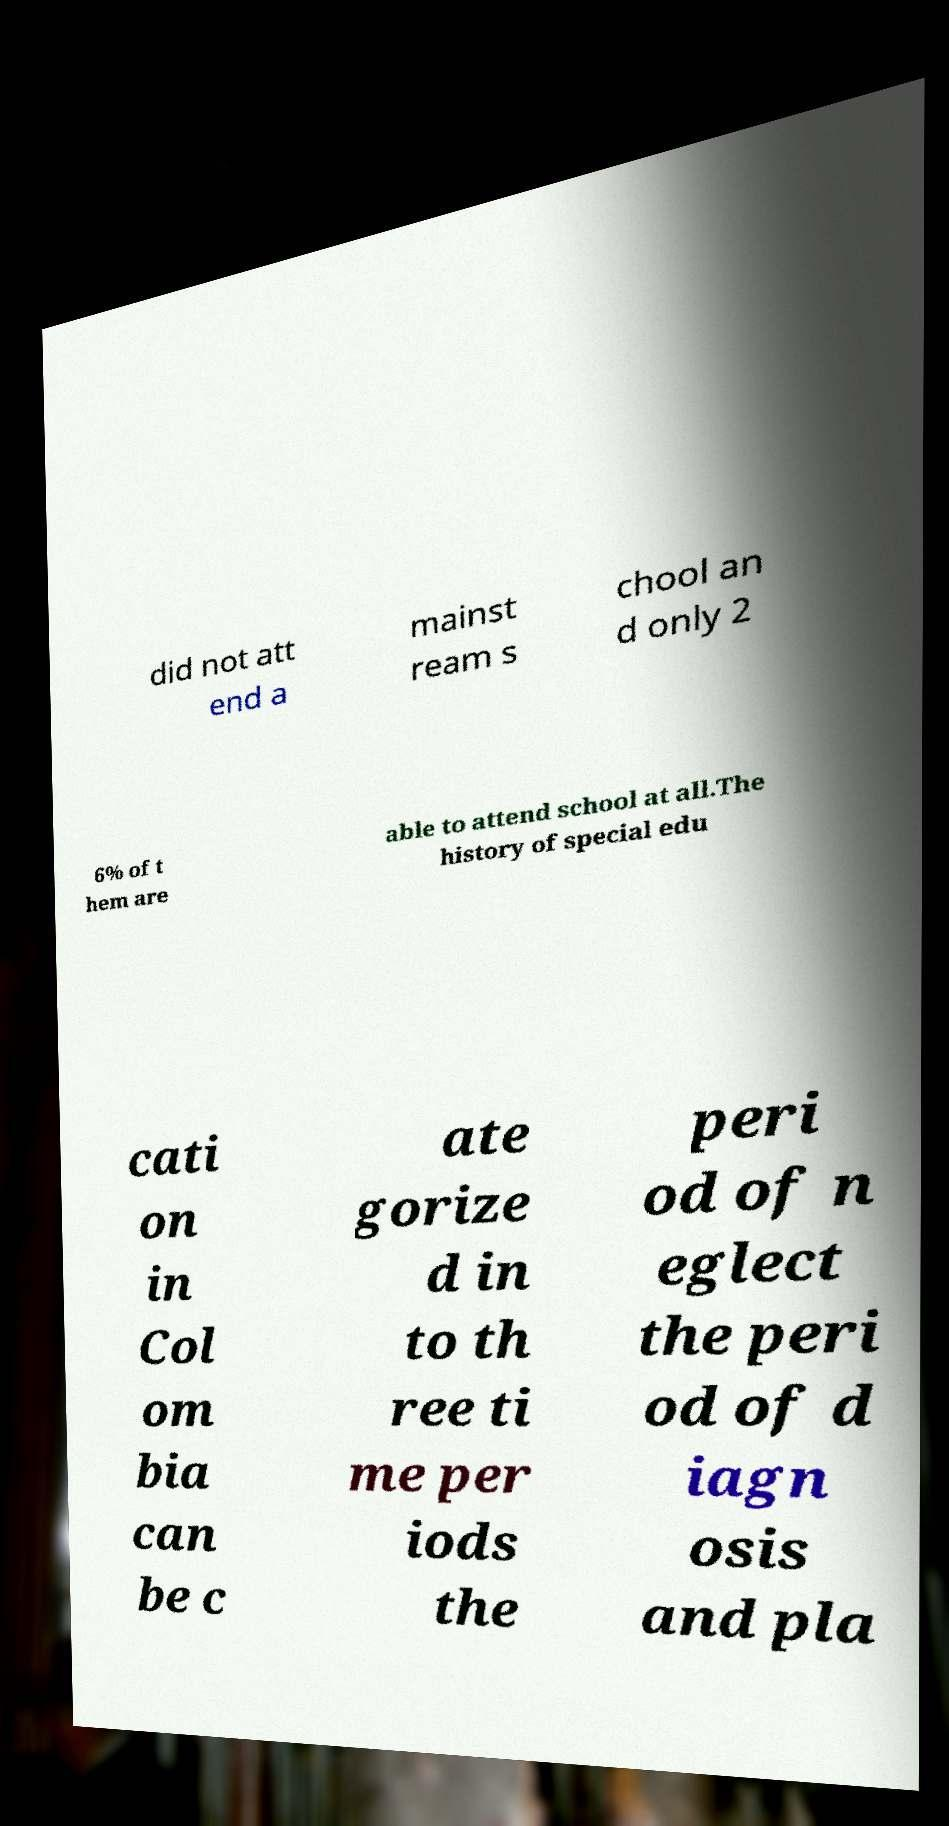There's text embedded in this image that I need extracted. Can you transcribe it verbatim? did not att end a mainst ream s chool an d only 2 6% of t hem are able to attend school at all.The history of special edu cati on in Col om bia can be c ate gorize d in to th ree ti me per iods the peri od of n eglect the peri od of d iagn osis and pla 